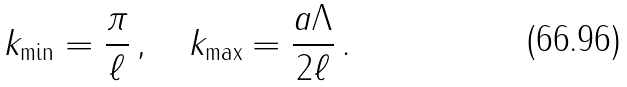<formula> <loc_0><loc_0><loc_500><loc_500>k _ { \min } = \frac { \pi } { \ell } \, , \quad k _ { \max } = \frac { a \Lambda } { 2 \ell } \, .</formula> 